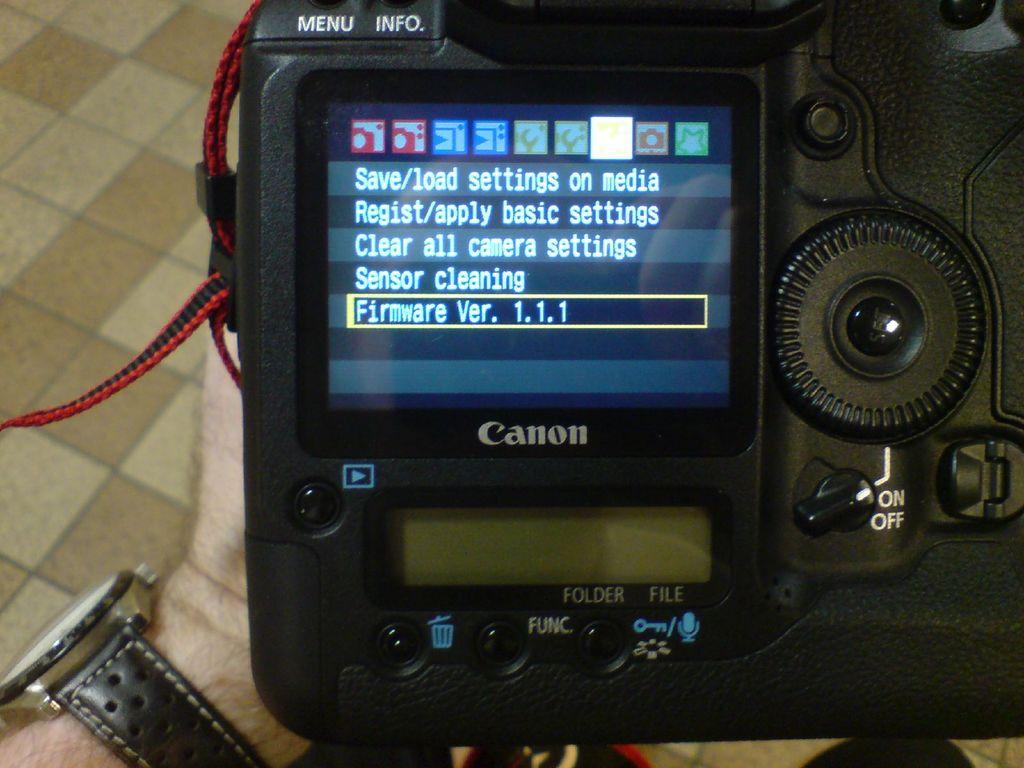What firmware version is this?
Give a very brief answer. 1.1.1. What brand is this camera?
Provide a succinct answer. Canon. 